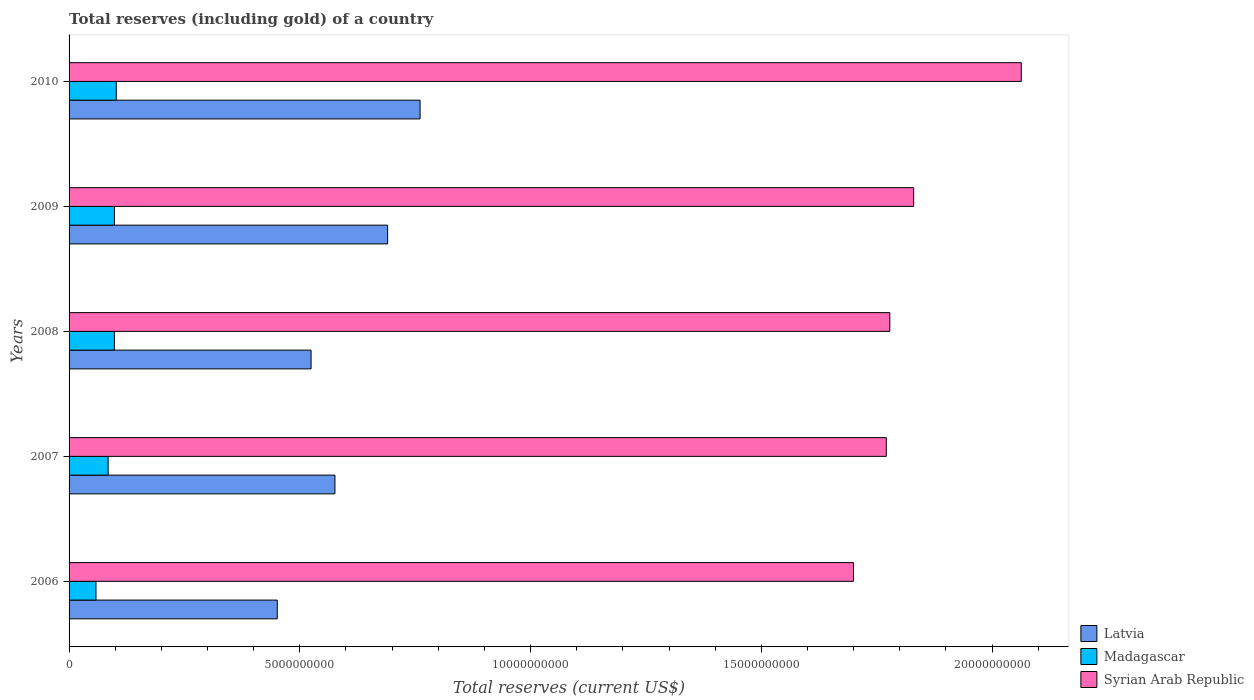How many different coloured bars are there?
Provide a short and direct response. 3. Are the number of bars on each tick of the Y-axis equal?
Give a very brief answer. Yes. How many bars are there on the 3rd tick from the bottom?
Your response must be concise. 3. What is the label of the 5th group of bars from the top?
Your answer should be compact. 2006. In how many cases, is the number of bars for a given year not equal to the number of legend labels?
Offer a very short reply. 0. What is the total reserves (including gold) in Syrian Arab Republic in 2009?
Your response must be concise. 1.83e+1. Across all years, what is the maximum total reserves (including gold) in Madagascar?
Keep it short and to the point. 1.02e+09. Across all years, what is the minimum total reserves (including gold) in Latvia?
Your answer should be compact. 4.51e+09. What is the total total reserves (including gold) in Latvia in the graph?
Offer a terse response. 3.00e+1. What is the difference between the total reserves (including gold) in Syrian Arab Republic in 2006 and that in 2009?
Your response must be concise. -1.30e+09. What is the difference between the total reserves (including gold) in Latvia in 2006 and the total reserves (including gold) in Madagascar in 2008?
Your answer should be very brief. 3.53e+09. What is the average total reserves (including gold) in Latvia per year?
Your answer should be compact. 6.00e+09. In the year 2007, what is the difference between the total reserves (including gold) in Madagascar and total reserves (including gold) in Syrian Arab Republic?
Offer a terse response. -1.69e+1. What is the ratio of the total reserves (including gold) in Madagascar in 2006 to that in 2008?
Provide a short and direct response. 0.59. Is the total reserves (including gold) in Syrian Arab Republic in 2009 less than that in 2010?
Your response must be concise. Yes. Is the difference between the total reserves (including gold) in Madagascar in 2006 and 2008 greater than the difference between the total reserves (including gold) in Syrian Arab Republic in 2006 and 2008?
Ensure brevity in your answer.  Yes. What is the difference between the highest and the second highest total reserves (including gold) in Madagascar?
Offer a very short reply. 4.07e+07. What is the difference between the highest and the lowest total reserves (including gold) in Madagascar?
Make the answer very short. 4.40e+08. In how many years, is the total reserves (including gold) in Latvia greater than the average total reserves (including gold) in Latvia taken over all years?
Provide a short and direct response. 2. Is the sum of the total reserves (including gold) in Madagascar in 2007 and 2009 greater than the maximum total reserves (including gold) in Latvia across all years?
Give a very brief answer. No. What does the 3rd bar from the top in 2008 represents?
Offer a terse response. Latvia. What does the 2nd bar from the bottom in 2010 represents?
Give a very brief answer. Madagascar. Is it the case that in every year, the sum of the total reserves (including gold) in Madagascar and total reserves (including gold) in Latvia is greater than the total reserves (including gold) in Syrian Arab Republic?
Provide a succinct answer. No. How many bars are there?
Offer a terse response. 15. Are all the bars in the graph horizontal?
Your response must be concise. Yes. What is the difference between two consecutive major ticks on the X-axis?
Give a very brief answer. 5.00e+09. Are the values on the major ticks of X-axis written in scientific E-notation?
Offer a very short reply. No. Does the graph contain any zero values?
Provide a succinct answer. No. Does the graph contain grids?
Ensure brevity in your answer.  No. How many legend labels are there?
Keep it short and to the point. 3. How are the legend labels stacked?
Keep it short and to the point. Vertical. What is the title of the graph?
Your answer should be very brief. Total reserves (including gold) of a country. What is the label or title of the X-axis?
Give a very brief answer. Total reserves (current US$). What is the label or title of the Y-axis?
Make the answer very short. Years. What is the Total reserves (current US$) in Latvia in 2006?
Offer a terse response. 4.51e+09. What is the Total reserves (current US$) in Madagascar in 2006?
Make the answer very short. 5.83e+08. What is the Total reserves (current US$) in Syrian Arab Republic in 2006?
Keep it short and to the point. 1.70e+1. What is the Total reserves (current US$) in Latvia in 2007?
Offer a very short reply. 5.76e+09. What is the Total reserves (current US$) in Madagascar in 2007?
Keep it short and to the point. 8.47e+08. What is the Total reserves (current US$) of Syrian Arab Republic in 2007?
Your answer should be compact. 1.77e+1. What is the Total reserves (current US$) of Latvia in 2008?
Your response must be concise. 5.24e+09. What is the Total reserves (current US$) in Madagascar in 2008?
Make the answer very short. 9.82e+08. What is the Total reserves (current US$) of Syrian Arab Republic in 2008?
Offer a terse response. 1.78e+1. What is the Total reserves (current US$) of Latvia in 2009?
Provide a short and direct response. 6.90e+09. What is the Total reserves (current US$) in Madagascar in 2009?
Give a very brief answer. 9.82e+08. What is the Total reserves (current US$) in Syrian Arab Republic in 2009?
Make the answer very short. 1.83e+1. What is the Total reserves (current US$) of Latvia in 2010?
Provide a succinct answer. 7.61e+09. What is the Total reserves (current US$) of Madagascar in 2010?
Ensure brevity in your answer.  1.02e+09. What is the Total reserves (current US$) of Syrian Arab Republic in 2010?
Your answer should be compact. 2.06e+1. Across all years, what is the maximum Total reserves (current US$) in Latvia?
Give a very brief answer. 7.61e+09. Across all years, what is the maximum Total reserves (current US$) of Madagascar?
Your answer should be very brief. 1.02e+09. Across all years, what is the maximum Total reserves (current US$) of Syrian Arab Republic?
Offer a terse response. 2.06e+1. Across all years, what is the minimum Total reserves (current US$) of Latvia?
Provide a succinct answer. 4.51e+09. Across all years, what is the minimum Total reserves (current US$) of Madagascar?
Give a very brief answer. 5.83e+08. Across all years, what is the minimum Total reserves (current US$) in Syrian Arab Republic?
Provide a succinct answer. 1.70e+1. What is the total Total reserves (current US$) of Latvia in the graph?
Keep it short and to the point. 3.00e+1. What is the total Total reserves (current US$) of Madagascar in the graph?
Offer a terse response. 4.42e+09. What is the total Total reserves (current US$) of Syrian Arab Republic in the graph?
Provide a short and direct response. 9.14e+1. What is the difference between the Total reserves (current US$) in Latvia in 2006 and that in 2007?
Offer a very short reply. -1.25e+09. What is the difference between the Total reserves (current US$) of Madagascar in 2006 and that in 2007?
Offer a terse response. -2.63e+08. What is the difference between the Total reserves (current US$) of Syrian Arab Republic in 2006 and that in 2007?
Provide a short and direct response. -7.11e+08. What is the difference between the Total reserves (current US$) of Latvia in 2006 and that in 2008?
Your response must be concise. -7.32e+08. What is the difference between the Total reserves (current US$) in Madagascar in 2006 and that in 2008?
Your answer should be very brief. -3.99e+08. What is the difference between the Total reserves (current US$) of Syrian Arab Republic in 2006 and that in 2008?
Give a very brief answer. -7.87e+08. What is the difference between the Total reserves (current US$) of Latvia in 2006 and that in 2009?
Ensure brevity in your answer.  -2.39e+09. What is the difference between the Total reserves (current US$) of Madagascar in 2006 and that in 2009?
Your response must be concise. -3.99e+08. What is the difference between the Total reserves (current US$) of Syrian Arab Republic in 2006 and that in 2009?
Offer a very short reply. -1.30e+09. What is the difference between the Total reserves (current US$) in Latvia in 2006 and that in 2010?
Give a very brief answer. -3.09e+09. What is the difference between the Total reserves (current US$) of Madagascar in 2006 and that in 2010?
Offer a very short reply. -4.40e+08. What is the difference between the Total reserves (current US$) in Syrian Arab Republic in 2006 and that in 2010?
Provide a short and direct response. -3.64e+09. What is the difference between the Total reserves (current US$) in Latvia in 2007 and that in 2008?
Ensure brevity in your answer.  5.17e+08. What is the difference between the Total reserves (current US$) of Madagascar in 2007 and that in 2008?
Give a very brief answer. -1.36e+08. What is the difference between the Total reserves (current US$) in Syrian Arab Republic in 2007 and that in 2008?
Provide a short and direct response. -7.63e+07. What is the difference between the Total reserves (current US$) of Latvia in 2007 and that in 2009?
Provide a short and direct response. -1.14e+09. What is the difference between the Total reserves (current US$) in Madagascar in 2007 and that in 2009?
Offer a terse response. -1.35e+08. What is the difference between the Total reserves (current US$) of Syrian Arab Republic in 2007 and that in 2009?
Give a very brief answer. -5.93e+08. What is the difference between the Total reserves (current US$) in Latvia in 2007 and that in 2010?
Provide a succinct answer. -1.84e+09. What is the difference between the Total reserves (current US$) in Madagascar in 2007 and that in 2010?
Ensure brevity in your answer.  -1.76e+08. What is the difference between the Total reserves (current US$) in Syrian Arab Republic in 2007 and that in 2010?
Make the answer very short. -2.92e+09. What is the difference between the Total reserves (current US$) in Latvia in 2008 and that in 2009?
Offer a very short reply. -1.66e+09. What is the difference between the Total reserves (current US$) in Madagascar in 2008 and that in 2009?
Give a very brief answer. 2.28e+05. What is the difference between the Total reserves (current US$) of Syrian Arab Republic in 2008 and that in 2009?
Offer a terse response. -5.17e+08. What is the difference between the Total reserves (current US$) in Latvia in 2008 and that in 2010?
Give a very brief answer. -2.36e+09. What is the difference between the Total reserves (current US$) in Madagascar in 2008 and that in 2010?
Your answer should be very brief. -4.07e+07. What is the difference between the Total reserves (current US$) in Syrian Arab Republic in 2008 and that in 2010?
Your answer should be very brief. -2.85e+09. What is the difference between the Total reserves (current US$) of Latvia in 2009 and that in 2010?
Your response must be concise. -7.03e+08. What is the difference between the Total reserves (current US$) of Madagascar in 2009 and that in 2010?
Your answer should be very brief. -4.09e+07. What is the difference between the Total reserves (current US$) in Syrian Arab Republic in 2009 and that in 2010?
Give a very brief answer. -2.33e+09. What is the difference between the Total reserves (current US$) of Latvia in 2006 and the Total reserves (current US$) of Madagascar in 2007?
Your answer should be very brief. 3.66e+09. What is the difference between the Total reserves (current US$) of Latvia in 2006 and the Total reserves (current US$) of Syrian Arab Republic in 2007?
Keep it short and to the point. -1.32e+1. What is the difference between the Total reserves (current US$) in Madagascar in 2006 and the Total reserves (current US$) in Syrian Arab Republic in 2007?
Give a very brief answer. -1.71e+1. What is the difference between the Total reserves (current US$) in Latvia in 2006 and the Total reserves (current US$) in Madagascar in 2008?
Your answer should be very brief. 3.53e+09. What is the difference between the Total reserves (current US$) of Latvia in 2006 and the Total reserves (current US$) of Syrian Arab Republic in 2008?
Make the answer very short. -1.33e+1. What is the difference between the Total reserves (current US$) in Madagascar in 2006 and the Total reserves (current US$) in Syrian Arab Republic in 2008?
Your response must be concise. -1.72e+1. What is the difference between the Total reserves (current US$) of Latvia in 2006 and the Total reserves (current US$) of Madagascar in 2009?
Offer a terse response. 3.53e+09. What is the difference between the Total reserves (current US$) in Latvia in 2006 and the Total reserves (current US$) in Syrian Arab Republic in 2009?
Keep it short and to the point. -1.38e+1. What is the difference between the Total reserves (current US$) in Madagascar in 2006 and the Total reserves (current US$) in Syrian Arab Republic in 2009?
Give a very brief answer. -1.77e+1. What is the difference between the Total reserves (current US$) of Latvia in 2006 and the Total reserves (current US$) of Madagascar in 2010?
Provide a succinct answer. 3.49e+09. What is the difference between the Total reserves (current US$) of Latvia in 2006 and the Total reserves (current US$) of Syrian Arab Republic in 2010?
Make the answer very short. -1.61e+1. What is the difference between the Total reserves (current US$) in Madagascar in 2006 and the Total reserves (current US$) in Syrian Arab Republic in 2010?
Make the answer very short. -2.00e+1. What is the difference between the Total reserves (current US$) of Latvia in 2007 and the Total reserves (current US$) of Madagascar in 2008?
Your answer should be compact. 4.78e+09. What is the difference between the Total reserves (current US$) in Latvia in 2007 and the Total reserves (current US$) in Syrian Arab Republic in 2008?
Provide a short and direct response. -1.20e+1. What is the difference between the Total reserves (current US$) in Madagascar in 2007 and the Total reserves (current US$) in Syrian Arab Republic in 2008?
Your answer should be compact. -1.69e+1. What is the difference between the Total reserves (current US$) in Latvia in 2007 and the Total reserves (current US$) in Madagascar in 2009?
Offer a very short reply. 4.78e+09. What is the difference between the Total reserves (current US$) of Latvia in 2007 and the Total reserves (current US$) of Syrian Arab Republic in 2009?
Your answer should be compact. -1.25e+1. What is the difference between the Total reserves (current US$) of Madagascar in 2007 and the Total reserves (current US$) of Syrian Arab Republic in 2009?
Your answer should be very brief. -1.75e+1. What is the difference between the Total reserves (current US$) in Latvia in 2007 and the Total reserves (current US$) in Madagascar in 2010?
Provide a succinct answer. 4.74e+09. What is the difference between the Total reserves (current US$) in Latvia in 2007 and the Total reserves (current US$) in Syrian Arab Republic in 2010?
Provide a short and direct response. -1.49e+1. What is the difference between the Total reserves (current US$) in Madagascar in 2007 and the Total reserves (current US$) in Syrian Arab Republic in 2010?
Provide a short and direct response. -1.98e+1. What is the difference between the Total reserves (current US$) of Latvia in 2008 and the Total reserves (current US$) of Madagascar in 2009?
Offer a very short reply. 4.26e+09. What is the difference between the Total reserves (current US$) of Latvia in 2008 and the Total reserves (current US$) of Syrian Arab Republic in 2009?
Offer a terse response. -1.31e+1. What is the difference between the Total reserves (current US$) of Madagascar in 2008 and the Total reserves (current US$) of Syrian Arab Republic in 2009?
Ensure brevity in your answer.  -1.73e+1. What is the difference between the Total reserves (current US$) of Latvia in 2008 and the Total reserves (current US$) of Madagascar in 2010?
Provide a short and direct response. 4.22e+09. What is the difference between the Total reserves (current US$) of Latvia in 2008 and the Total reserves (current US$) of Syrian Arab Republic in 2010?
Give a very brief answer. -1.54e+1. What is the difference between the Total reserves (current US$) of Madagascar in 2008 and the Total reserves (current US$) of Syrian Arab Republic in 2010?
Ensure brevity in your answer.  -1.96e+1. What is the difference between the Total reserves (current US$) of Latvia in 2009 and the Total reserves (current US$) of Madagascar in 2010?
Keep it short and to the point. 5.88e+09. What is the difference between the Total reserves (current US$) in Latvia in 2009 and the Total reserves (current US$) in Syrian Arab Republic in 2010?
Your response must be concise. -1.37e+1. What is the difference between the Total reserves (current US$) of Madagascar in 2009 and the Total reserves (current US$) of Syrian Arab Republic in 2010?
Make the answer very short. -1.96e+1. What is the average Total reserves (current US$) in Latvia per year?
Make the answer very short. 6.00e+09. What is the average Total reserves (current US$) of Madagascar per year?
Keep it short and to the point. 8.83e+08. What is the average Total reserves (current US$) of Syrian Arab Republic per year?
Keep it short and to the point. 1.83e+1. In the year 2006, what is the difference between the Total reserves (current US$) of Latvia and Total reserves (current US$) of Madagascar?
Keep it short and to the point. 3.93e+09. In the year 2006, what is the difference between the Total reserves (current US$) of Latvia and Total reserves (current US$) of Syrian Arab Republic?
Offer a terse response. -1.25e+1. In the year 2006, what is the difference between the Total reserves (current US$) in Madagascar and Total reserves (current US$) in Syrian Arab Republic?
Make the answer very short. -1.64e+1. In the year 2007, what is the difference between the Total reserves (current US$) of Latvia and Total reserves (current US$) of Madagascar?
Make the answer very short. 4.91e+09. In the year 2007, what is the difference between the Total reserves (current US$) in Latvia and Total reserves (current US$) in Syrian Arab Republic?
Make the answer very short. -1.19e+1. In the year 2007, what is the difference between the Total reserves (current US$) of Madagascar and Total reserves (current US$) of Syrian Arab Republic?
Your answer should be compact. -1.69e+1. In the year 2008, what is the difference between the Total reserves (current US$) in Latvia and Total reserves (current US$) in Madagascar?
Your response must be concise. 4.26e+09. In the year 2008, what is the difference between the Total reserves (current US$) in Latvia and Total reserves (current US$) in Syrian Arab Republic?
Give a very brief answer. -1.25e+1. In the year 2008, what is the difference between the Total reserves (current US$) in Madagascar and Total reserves (current US$) in Syrian Arab Republic?
Ensure brevity in your answer.  -1.68e+1. In the year 2009, what is the difference between the Total reserves (current US$) of Latvia and Total reserves (current US$) of Madagascar?
Offer a very short reply. 5.92e+09. In the year 2009, what is the difference between the Total reserves (current US$) in Latvia and Total reserves (current US$) in Syrian Arab Republic?
Offer a terse response. -1.14e+1. In the year 2009, what is the difference between the Total reserves (current US$) of Madagascar and Total reserves (current US$) of Syrian Arab Republic?
Your answer should be compact. -1.73e+1. In the year 2010, what is the difference between the Total reserves (current US$) of Latvia and Total reserves (current US$) of Madagascar?
Your answer should be compact. 6.58e+09. In the year 2010, what is the difference between the Total reserves (current US$) in Latvia and Total reserves (current US$) in Syrian Arab Republic?
Provide a short and direct response. -1.30e+1. In the year 2010, what is the difference between the Total reserves (current US$) in Madagascar and Total reserves (current US$) in Syrian Arab Republic?
Give a very brief answer. -1.96e+1. What is the ratio of the Total reserves (current US$) of Latvia in 2006 to that in 2007?
Your answer should be very brief. 0.78. What is the ratio of the Total reserves (current US$) in Madagascar in 2006 to that in 2007?
Keep it short and to the point. 0.69. What is the ratio of the Total reserves (current US$) in Syrian Arab Republic in 2006 to that in 2007?
Offer a terse response. 0.96. What is the ratio of the Total reserves (current US$) of Latvia in 2006 to that in 2008?
Offer a terse response. 0.86. What is the ratio of the Total reserves (current US$) in Madagascar in 2006 to that in 2008?
Give a very brief answer. 0.59. What is the ratio of the Total reserves (current US$) in Syrian Arab Republic in 2006 to that in 2008?
Give a very brief answer. 0.96. What is the ratio of the Total reserves (current US$) of Latvia in 2006 to that in 2009?
Make the answer very short. 0.65. What is the ratio of the Total reserves (current US$) of Madagascar in 2006 to that in 2009?
Your answer should be very brief. 0.59. What is the ratio of the Total reserves (current US$) of Syrian Arab Republic in 2006 to that in 2009?
Keep it short and to the point. 0.93. What is the ratio of the Total reserves (current US$) of Latvia in 2006 to that in 2010?
Your answer should be very brief. 0.59. What is the ratio of the Total reserves (current US$) of Madagascar in 2006 to that in 2010?
Your answer should be very brief. 0.57. What is the ratio of the Total reserves (current US$) of Syrian Arab Republic in 2006 to that in 2010?
Give a very brief answer. 0.82. What is the ratio of the Total reserves (current US$) of Latvia in 2007 to that in 2008?
Keep it short and to the point. 1.1. What is the ratio of the Total reserves (current US$) in Madagascar in 2007 to that in 2008?
Ensure brevity in your answer.  0.86. What is the ratio of the Total reserves (current US$) in Syrian Arab Republic in 2007 to that in 2008?
Keep it short and to the point. 1. What is the ratio of the Total reserves (current US$) in Latvia in 2007 to that in 2009?
Keep it short and to the point. 0.83. What is the ratio of the Total reserves (current US$) of Madagascar in 2007 to that in 2009?
Your answer should be very brief. 0.86. What is the ratio of the Total reserves (current US$) of Syrian Arab Republic in 2007 to that in 2009?
Provide a succinct answer. 0.97. What is the ratio of the Total reserves (current US$) in Latvia in 2007 to that in 2010?
Your response must be concise. 0.76. What is the ratio of the Total reserves (current US$) in Madagascar in 2007 to that in 2010?
Provide a succinct answer. 0.83. What is the ratio of the Total reserves (current US$) of Syrian Arab Republic in 2007 to that in 2010?
Provide a succinct answer. 0.86. What is the ratio of the Total reserves (current US$) in Latvia in 2008 to that in 2009?
Your response must be concise. 0.76. What is the ratio of the Total reserves (current US$) of Madagascar in 2008 to that in 2009?
Provide a short and direct response. 1. What is the ratio of the Total reserves (current US$) of Syrian Arab Republic in 2008 to that in 2009?
Offer a terse response. 0.97. What is the ratio of the Total reserves (current US$) in Latvia in 2008 to that in 2010?
Keep it short and to the point. 0.69. What is the ratio of the Total reserves (current US$) in Madagascar in 2008 to that in 2010?
Give a very brief answer. 0.96. What is the ratio of the Total reserves (current US$) of Syrian Arab Republic in 2008 to that in 2010?
Provide a succinct answer. 0.86. What is the ratio of the Total reserves (current US$) in Latvia in 2009 to that in 2010?
Your response must be concise. 0.91. What is the ratio of the Total reserves (current US$) of Syrian Arab Republic in 2009 to that in 2010?
Provide a succinct answer. 0.89. What is the difference between the highest and the second highest Total reserves (current US$) of Latvia?
Make the answer very short. 7.03e+08. What is the difference between the highest and the second highest Total reserves (current US$) in Madagascar?
Make the answer very short. 4.07e+07. What is the difference between the highest and the second highest Total reserves (current US$) in Syrian Arab Republic?
Offer a terse response. 2.33e+09. What is the difference between the highest and the lowest Total reserves (current US$) in Latvia?
Your response must be concise. 3.09e+09. What is the difference between the highest and the lowest Total reserves (current US$) of Madagascar?
Offer a terse response. 4.40e+08. What is the difference between the highest and the lowest Total reserves (current US$) in Syrian Arab Republic?
Provide a succinct answer. 3.64e+09. 